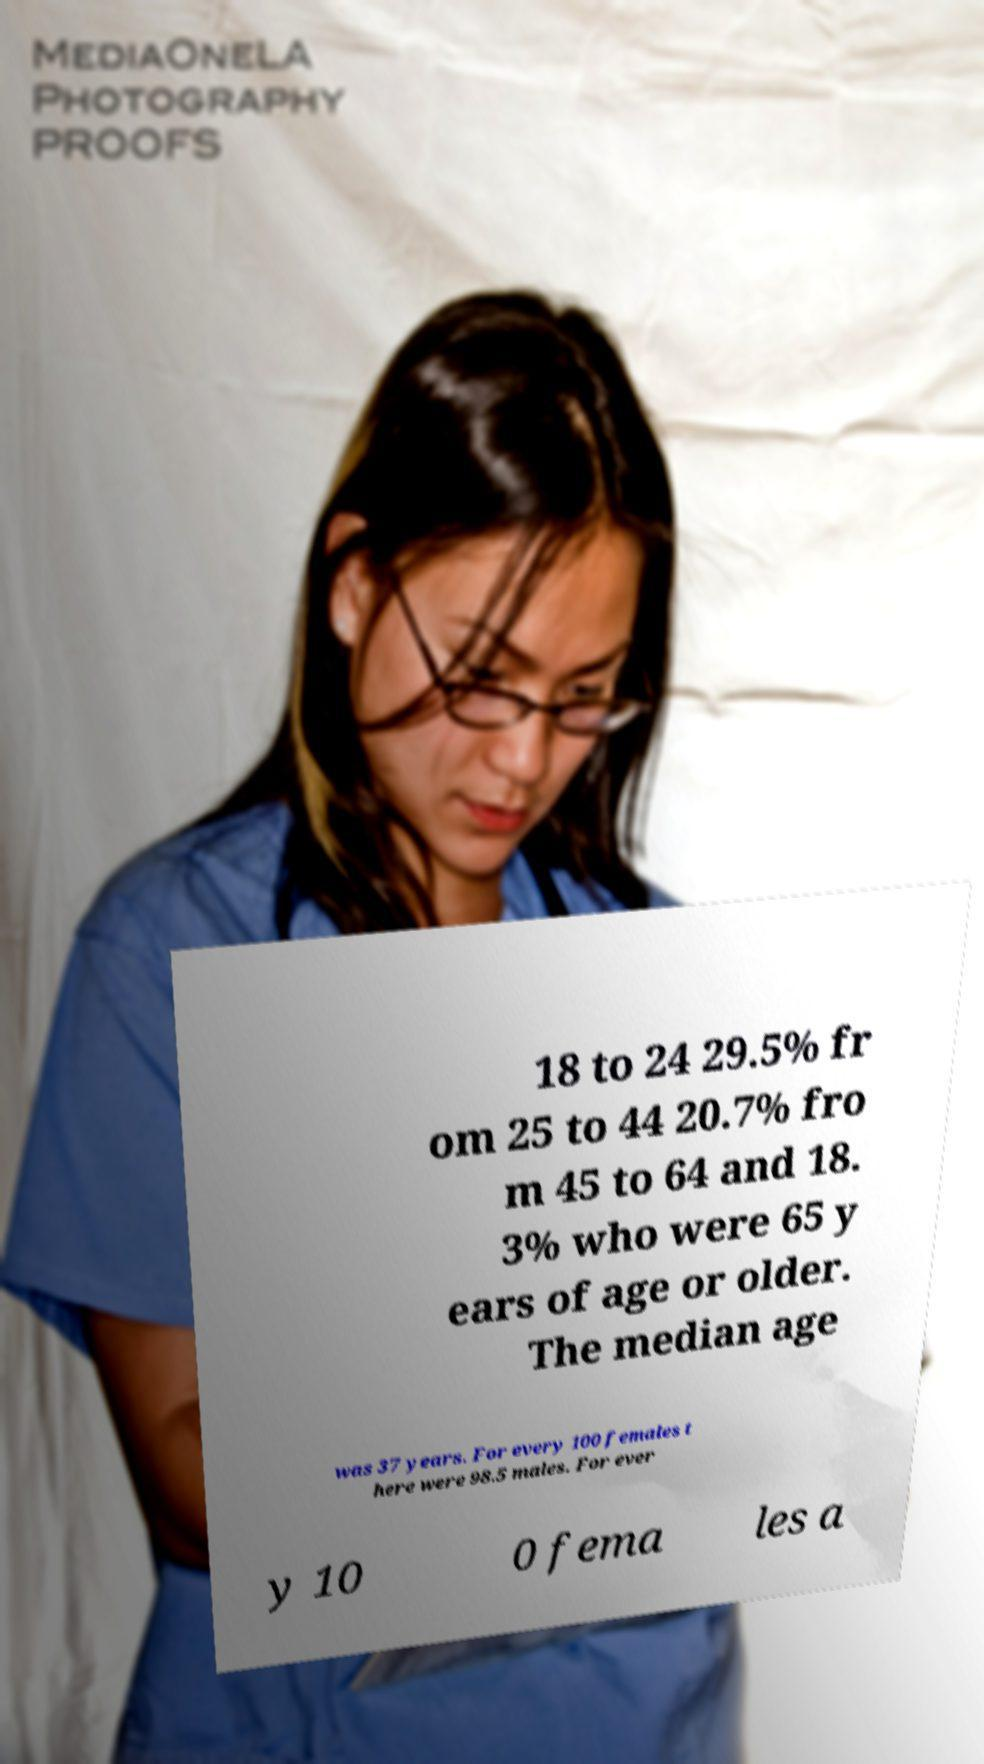I need the written content from this picture converted into text. Can you do that? 18 to 24 29.5% fr om 25 to 44 20.7% fro m 45 to 64 and 18. 3% who were 65 y ears of age or older. The median age was 37 years. For every 100 females t here were 98.5 males. For ever y 10 0 fema les a 